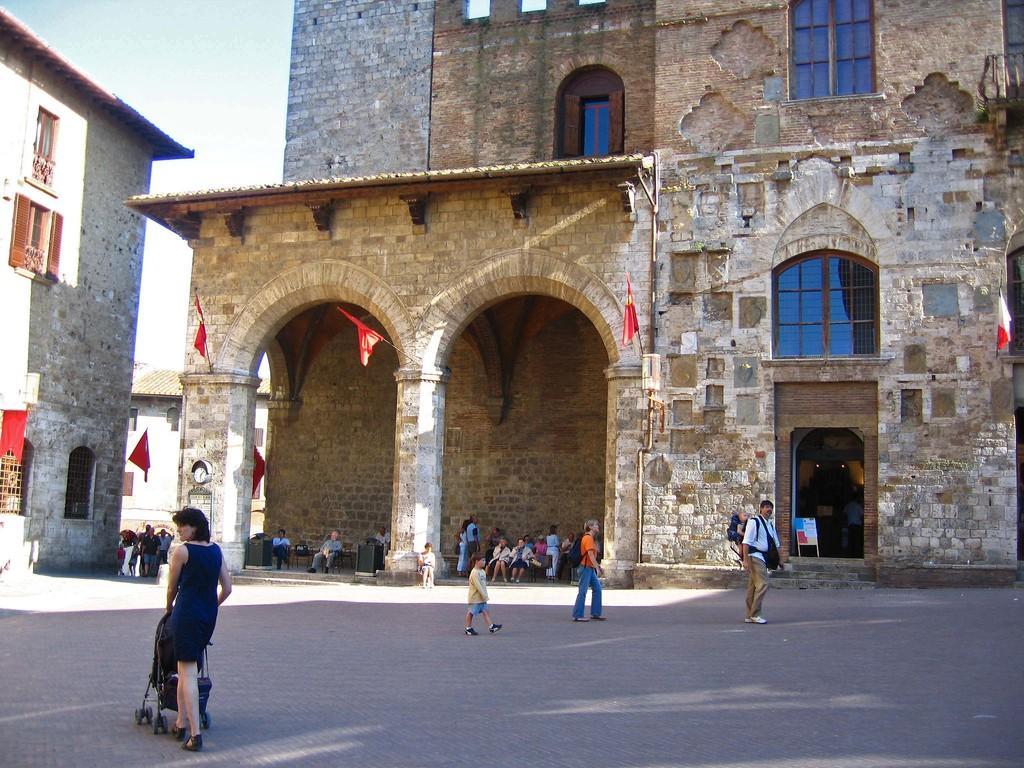Could you give a brief overview of what you see in this image? In this image we can see group of people standing on the floor. One woman wearing blue dress is holding a baby carrier. In the background,we can see a building with group of flags ,windows on it. To the left side of the image we can see a building group of people standing and some people standing on chairs and the sky. 